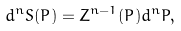<formula> <loc_0><loc_0><loc_500><loc_500>d ^ { n } S ( P ) = Z ^ { n - 1 } ( P ) d ^ { n } P ,</formula> 